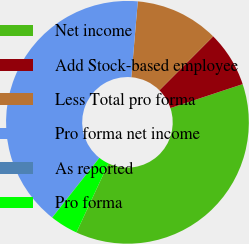Convert chart to OTSL. <chart><loc_0><loc_0><loc_500><loc_500><pie_chart><fcel>Net income<fcel>Add Stock-based employee<fcel>Less Total pro forma<fcel>Pro forma net income<fcel>As reported<fcel>Pro forma<nl><fcel>37.0%<fcel>7.43%<fcel>11.12%<fcel>40.69%<fcel>0.03%<fcel>3.73%<nl></chart> 